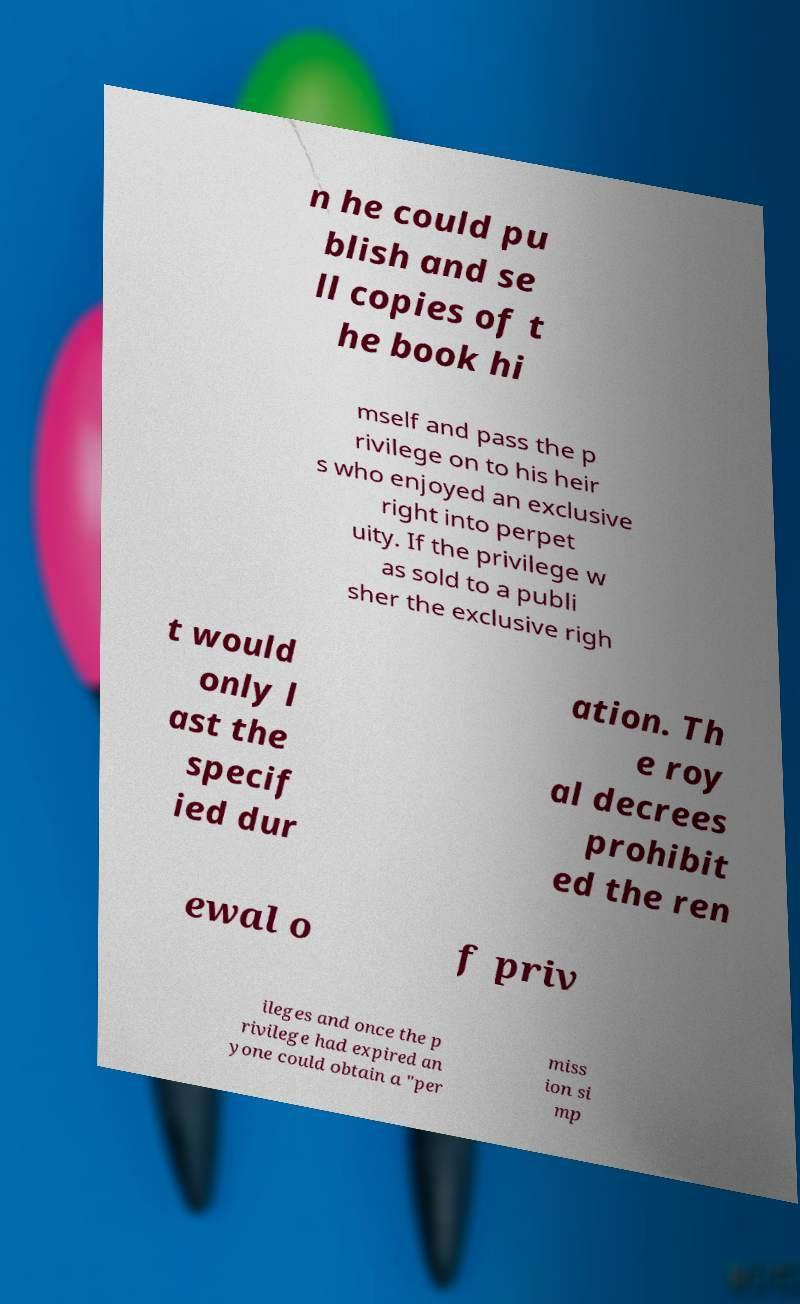I need the written content from this picture converted into text. Can you do that? n he could pu blish and se ll copies of t he book hi mself and pass the p rivilege on to his heir s who enjoyed an exclusive right into perpet uity. If the privilege w as sold to a publi sher the exclusive righ t would only l ast the specif ied dur ation. Th e roy al decrees prohibit ed the ren ewal o f priv ileges and once the p rivilege had expired an yone could obtain a "per miss ion si mp 